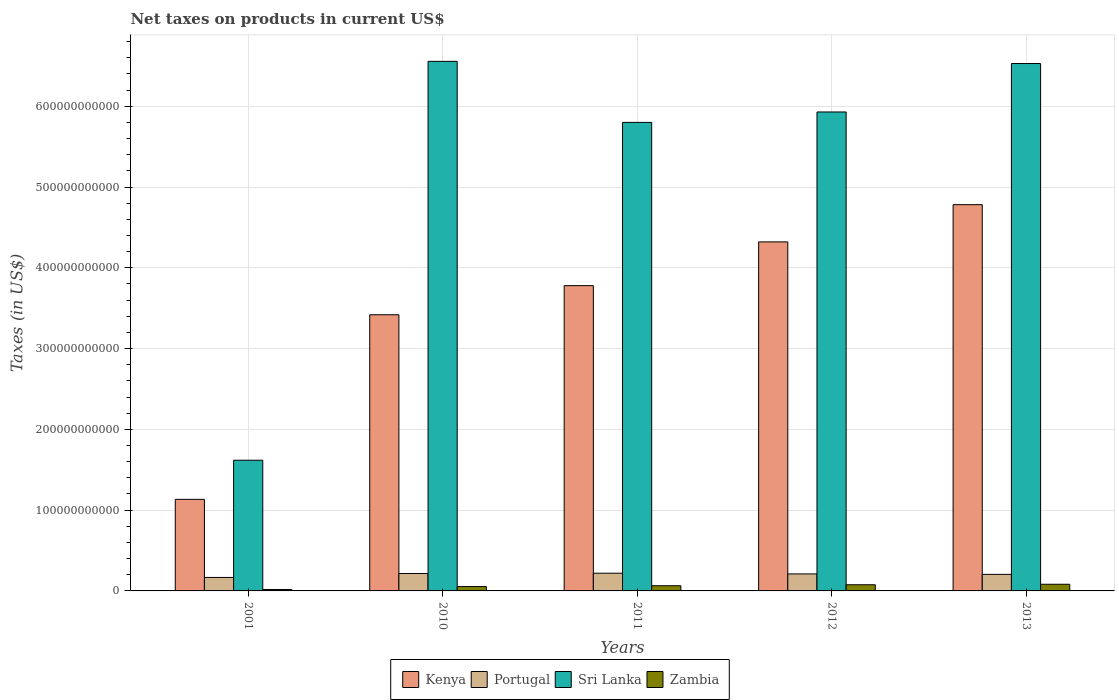How many different coloured bars are there?
Provide a short and direct response. 4. How many groups of bars are there?
Make the answer very short. 5. Are the number of bars per tick equal to the number of legend labels?
Keep it short and to the point. Yes. How many bars are there on the 5th tick from the left?
Your response must be concise. 4. In how many cases, is the number of bars for a given year not equal to the number of legend labels?
Give a very brief answer. 0. What is the net taxes on products in Sri Lanka in 2011?
Your answer should be very brief. 5.80e+11. Across all years, what is the maximum net taxes on products in Zambia?
Provide a short and direct response. 8.26e+09. Across all years, what is the minimum net taxes on products in Portugal?
Keep it short and to the point. 1.67e+1. In which year was the net taxes on products in Portugal maximum?
Provide a short and direct response. 2011. In which year was the net taxes on products in Portugal minimum?
Offer a very short reply. 2001. What is the total net taxes on products in Portugal in the graph?
Offer a very short reply. 1.02e+11. What is the difference between the net taxes on products in Sri Lanka in 2010 and that in 2011?
Offer a very short reply. 7.56e+1. What is the difference between the net taxes on products in Kenya in 2001 and the net taxes on products in Sri Lanka in 2012?
Provide a succinct answer. -4.80e+11. What is the average net taxes on products in Kenya per year?
Your response must be concise. 3.49e+11. In the year 2010, what is the difference between the net taxes on products in Kenya and net taxes on products in Portugal?
Ensure brevity in your answer.  3.20e+11. In how many years, is the net taxes on products in Kenya greater than 540000000000 US$?
Provide a short and direct response. 0. What is the ratio of the net taxes on products in Kenya in 2010 to that in 2012?
Offer a very short reply. 0.79. Is the difference between the net taxes on products in Kenya in 2010 and 2011 greater than the difference between the net taxes on products in Portugal in 2010 and 2011?
Offer a very short reply. No. What is the difference between the highest and the second highest net taxes on products in Portugal?
Give a very brief answer. 3.20e+08. What is the difference between the highest and the lowest net taxes on products in Zambia?
Offer a very short reply. 6.48e+09. Is the sum of the net taxes on products in Portugal in 2011 and 2012 greater than the maximum net taxes on products in Sri Lanka across all years?
Provide a short and direct response. No. Is it the case that in every year, the sum of the net taxes on products in Kenya and net taxes on products in Portugal is greater than the sum of net taxes on products in Zambia and net taxes on products in Sri Lanka?
Make the answer very short. Yes. What does the 1st bar from the left in 2011 represents?
Offer a terse response. Kenya. What does the 4th bar from the right in 2011 represents?
Ensure brevity in your answer.  Kenya. Is it the case that in every year, the sum of the net taxes on products in Sri Lanka and net taxes on products in Portugal is greater than the net taxes on products in Kenya?
Ensure brevity in your answer.  Yes. How many bars are there?
Ensure brevity in your answer.  20. How many years are there in the graph?
Your answer should be compact. 5. What is the difference between two consecutive major ticks on the Y-axis?
Your answer should be compact. 1.00e+11. Are the values on the major ticks of Y-axis written in scientific E-notation?
Ensure brevity in your answer.  No. Does the graph contain any zero values?
Keep it short and to the point. No. Does the graph contain grids?
Give a very brief answer. Yes. How many legend labels are there?
Provide a short and direct response. 4. How are the legend labels stacked?
Your answer should be compact. Horizontal. What is the title of the graph?
Keep it short and to the point. Net taxes on products in current US$. What is the label or title of the Y-axis?
Your answer should be very brief. Taxes (in US$). What is the Taxes (in US$) in Kenya in 2001?
Your response must be concise. 1.13e+11. What is the Taxes (in US$) in Portugal in 2001?
Keep it short and to the point. 1.67e+1. What is the Taxes (in US$) of Sri Lanka in 2001?
Provide a succinct answer. 1.62e+11. What is the Taxes (in US$) in Zambia in 2001?
Your answer should be very brief. 1.78e+09. What is the Taxes (in US$) in Kenya in 2010?
Provide a short and direct response. 3.42e+11. What is the Taxes (in US$) in Portugal in 2010?
Make the answer very short. 2.16e+1. What is the Taxes (in US$) in Sri Lanka in 2010?
Your answer should be compact. 6.56e+11. What is the Taxes (in US$) in Zambia in 2010?
Your response must be concise. 5.38e+09. What is the Taxes (in US$) in Kenya in 2011?
Your answer should be compact. 3.78e+11. What is the Taxes (in US$) in Portugal in 2011?
Your response must be concise. 2.19e+1. What is the Taxes (in US$) of Sri Lanka in 2011?
Your response must be concise. 5.80e+11. What is the Taxes (in US$) of Zambia in 2011?
Provide a succinct answer. 6.43e+09. What is the Taxes (in US$) of Kenya in 2012?
Make the answer very short. 4.32e+11. What is the Taxes (in US$) in Portugal in 2012?
Offer a very short reply. 2.10e+1. What is the Taxes (in US$) in Sri Lanka in 2012?
Your answer should be compact. 5.93e+11. What is the Taxes (in US$) in Zambia in 2012?
Your response must be concise. 7.63e+09. What is the Taxes (in US$) of Kenya in 2013?
Keep it short and to the point. 4.78e+11. What is the Taxes (in US$) in Portugal in 2013?
Provide a short and direct response. 2.05e+1. What is the Taxes (in US$) of Sri Lanka in 2013?
Your response must be concise. 6.53e+11. What is the Taxes (in US$) in Zambia in 2013?
Your answer should be very brief. 8.26e+09. Across all years, what is the maximum Taxes (in US$) in Kenya?
Give a very brief answer. 4.78e+11. Across all years, what is the maximum Taxes (in US$) in Portugal?
Provide a succinct answer. 2.19e+1. Across all years, what is the maximum Taxes (in US$) in Sri Lanka?
Keep it short and to the point. 6.56e+11. Across all years, what is the maximum Taxes (in US$) of Zambia?
Provide a succinct answer. 8.26e+09. Across all years, what is the minimum Taxes (in US$) of Kenya?
Your answer should be very brief. 1.13e+11. Across all years, what is the minimum Taxes (in US$) in Portugal?
Ensure brevity in your answer.  1.67e+1. Across all years, what is the minimum Taxes (in US$) in Sri Lanka?
Offer a terse response. 1.62e+11. Across all years, what is the minimum Taxes (in US$) in Zambia?
Make the answer very short. 1.78e+09. What is the total Taxes (in US$) in Kenya in the graph?
Ensure brevity in your answer.  1.74e+12. What is the total Taxes (in US$) of Portugal in the graph?
Ensure brevity in your answer.  1.02e+11. What is the total Taxes (in US$) in Sri Lanka in the graph?
Make the answer very short. 2.64e+12. What is the total Taxes (in US$) of Zambia in the graph?
Your response must be concise. 2.95e+1. What is the difference between the Taxes (in US$) of Kenya in 2001 and that in 2010?
Keep it short and to the point. -2.29e+11. What is the difference between the Taxes (in US$) of Portugal in 2001 and that in 2010?
Your response must be concise. -4.92e+09. What is the difference between the Taxes (in US$) of Sri Lanka in 2001 and that in 2010?
Offer a terse response. -4.94e+11. What is the difference between the Taxes (in US$) of Zambia in 2001 and that in 2010?
Provide a succinct answer. -3.60e+09. What is the difference between the Taxes (in US$) in Kenya in 2001 and that in 2011?
Ensure brevity in your answer.  -2.65e+11. What is the difference between the Taxes (in US$) in Portugal in 2001 and that in 2011?
Keep it short and to the point. -5.24e+09. What is the difference between the Taxes (in US$) in Sri Lanka in 2001 and that in 2011?
Provide a short and direct response. -4.18e+11. What is the difference between the Taxes (in US$) in Zambia in 2001 and that in 2011?
Ensure brevity in your answer.  -4.65e+09. What is the difference between the Taxes (in US$) in Kenya in 2001 and that in 2012?
Your answer should be compact. -3.19e+11. What is the difference between the Taxes (in US$) of Portugal in 2001 and that in 2012?
Provide a short and direct response. -4.35e+09. What is the difference between the Taxes (in US$) of Sri Lanka in 2001 and that in 2012?
Make the answer very short. -4.31e+11. What is the difference between the Taxes (in US$) of Zambia in 2001 and that in 2012?
Provide a short and direct response. -5.86e+09. What is the difference between the Taxes (in US$) in Kenya in 2001 and that in 2013?
Offer a terse response. -3.65e+11. What is the difference between the Taxes (in US$) in Portugal in 2001 and that in 2013?
Provide a short and direct response. -3.82e+09. What is the difference between the Taxes (in US$) of Sri Lanka in 2001 and that in 2013?
Ensure brevity in your answer.  -4.91e+11. What is the difference between the Taxes (in US$) in Zambia in 2001 and that in 2013?
Offer a terse response. -6.48e+09. What is the difference between the Taxes (in US$) of Kenya in 2010 and that in 2011?
Give a very brief answer. -3.61e+1. What is the difference between the Taxes (in US$) of Portugal in 2010 and that in 2011?
Make the answer very short. -3.20e+08. What is the difference between the Taxes (in US$) in Sri Lanka in 2010 and that in 2011?
Your answer should be compact. 7.56e+1. What is the difference between the Taxes (in US$) of Zambia in 2010 and that in 2011?
Provide a succinct answer. -1.05e+09. What is the difference between the Taxes (in US$) in Kenya in 2010 and that in 2012?
Make the answer very short. -9.02e+1. What is the difference between the Taxes (in US$) of Portugal in 2010 and that in 2012?
Provide a short and direct response. 5.68e+08. What is the difference between the Taxes (in US$) in Sri Lanka in 2010 and that in 2012?
Provide a short and direct response. 6.27e+1. What is the difference between the Taxes (in US$) of Zambia in 2010 and that in 2012?
Offer a terse response. -2.25e+09. What is the difference between the Taxes (in US$) of Kenya in 2010 and that in 2013?
Offer a very short reply. -1.36e+11. What is the difference between the Taxes (in US$) of Portugal in 2010 and that in 2013?
Your response must be concise. 1.10e+09. What is the difference between the Taxes (in US$) of Sri Lanka in 2010 and that in 2013?
Provide a short and direct response. 2.69e+09. What is the difference between the Taxes (in US$) of Zambia in 2010 and that in 2013?
Ensure brevity in your answer.  -2.88e+09. What is the difference between the Taxes (in US$) in Kenya in 2011 and that in 2012?
Your answer should be very brief. -5.41e+1. What is the difference between the Taxes (in US$) in Portugal in 2011 and that in 2012?
Your answer should be compact. 8.87e+08. What is the difference between the Taxes (in US$) of Sri Lanka in 2011 and that in 2012?
Make the answer very short. -1.29e+1. What is the difference between the Taxes (in US$) of Zambia in 2011 and that in 2012?
Provide a short and direct response. -1.21e+09. What is the difference between the Taxes (in US$) in Kenya in 2011 and that in 2013?
Keep it short and to the point. -1.00e+11. What is the difference between the Taxes (in US$) in Portugal in 2011 and that in 2013?
Make the answer very short. 1.42e+09. What is the difference between the Taxes (in US$) of Sri Lanka in 2011 and that in 2013?
Provide a short and direct response. -7.29e+1. What is the difference between the Taxes (in US$) of Zambia in 2011 and that in 2013?
Ensure brevity in your answer.  -1.83e+09. What is the difference between the Taxes (in US$) of Kenya in 2012 and that in 2013?
Ensure brevity in your answer.  -4.61e+1. What is the difference between the Taxes (in US$) in Portugal in 2012 and that in 2013?
Provide a succinct answer. 5.35e+08. What is the difference between the Taxes (in US$) in Sri Lanka in 2012 and that in 2013?
Offer a very short reply. -6.00e+1. What is the difference between the Taxes (in US$) in Zambia in 2012 and that in 2013?
Your response must be concise. -6.24e+08. What is the difference between the Taxes (in US$) of Kenya in 2001 and the Taxes (in US$) of Portugal in 2010?
Offer a terse response. 9.17e+1. What is the difference between the Taxes (in US$) of Kenya in 2001 and the Taxes (in US$) of Sri Lanka in 2010?
Give a very brief answer. -5.42e+11. What is the difference between the Taxes (in US$) in Kenya in 2001 and the Taxes (in US$) in Zambia in 2010?
Provide a succinct answer. 1.08e+11. What is the difference between the Taxes (in US$) of Portugal in 2001 and the Taxes (in US$) of Sri Lanka in 2010?
Give a very brief answer. -6.39e+11. What is the difference between the Taxes (in US$) in Portugal in 2001 and the Taxes (in US$) in Zambia in 2010?
Your answer should be compact. 1.13e+1. What is the difference between the Taxes (in US$) of Sri Lanka in 2001 and the Taxes (in US$) of Zambia in 2010?
Keep it short and to the point. 1.56e+11. What is the difference between the Taxes (in US$) in Kenya in 2001 and the Taxes (in US$) in Portugal in 2011?
Make the answer very short. 9.14e+1. What is the difference between the Taxes (in US$) in Kenya in 2001 and the Taxes (in US$) in Sri Lanka in 2011?
Your response must be concise. -4.67e+11. What is the difference between the Taxes (in US$) of Kenya in 2001 and the Taxes (in US$) of Zambia in 2011?
Keep it short and to the point. 1.07e+11. What is the difference between the Taxes (in US$) of Portugal in 2001 and the Taxes (in US$) of Sri Lanka in 2011?
Provide a short and direct response. -5.63e+11. What is the difference between the Taxes (in US$) in Portugal in 2001 and the Taxes (in US$) in Zambia in 2011?
Your answer should be compact. 1.03e+1. What is the difference between the Taxes (in US$) of Sri Lanka in 2001 and the Taxes (in US$) of Zambia in 2011?
Your answer should be very brief. 1.55e+11. What is the difference between the Taxes (in US$) in Kenya in 2001 and the Taxes (in US$) in Portugal in 2012?
Your answer should be very brief. 9.23e+1. What is the difference between the Taxes (in US$) of Kenya in 2001 and the Taxes (in US$) of Sri Lanka in 2012?
Keep it short and to the point. -4.80e+11. What is the difference between the Taxes (in US$) of Kenya in 2001 and the Taxes (in US$) of Zambia in 2012?
Provide a succinct answer. 1.06e+11. What is the difference between the Taxes (in US$) of Portugal in 2001 and the Taxes (in US$) of Sri Lanka in 2012?
Offer a terse response. -5.76e+11. What is the difference between the Taxes (in US$) of Portugal in 2001 and the Taxes (in US$) of Zambia in 2012?
Your answer should be very brief. 9.05e+09. What is the difference between the Taxes (in US$) in Sri Lanka in 2001 and the Taxes (in US$) in Zambia in 2012?
Offer a very short reply. 1.54e+11. What is the difference between the Taxes (in US$) in Kenya in 2001 and the Taxes (in US$) in Portugal in 2013?
Make the answer very short. 9.28e+1. What is the difference between the Taxes (in US$) in Kenya in 2001 and the Taxes (in US$) in Sri Lanka in 2013?
Your response must be concise. -5.40e+11. What is the difference between the Taxes (in US$) in Kenya in 2001 and the Taxes (in US$) in Zambia in 2013?
Your answer should be very brief. 1.05e+11. What is the difference between the Taxes (in US$) of Portugal in 2001 and the Taxes (in US$) of Sri Lanka in 2013?
Make the answer very short. -6.36e+11. What is the difference between the Taxes (in US$) of Portugal in 2001 and the Taxes (in US$) of Zambia in 2013?
Your answer should be very brief. 8.43e+09. What is the difference between the Taxes (in US$) of Sri Lanka in 2001 and the Taxes (in US$) of Zambia in 2013?
Your answer should be very brief. 1.54e+11. What is the difference between the Taxes (in US$) of Kenya in 2010 and the Taxes (in US$) of Portugal in 2011?
Your answer should be very brief. 3.20e+11. What is the difference between the Taxes (in US$) of Kenya in 2010 and the Taxes (in US$) of Sri Lanka in 2011?
Give a very brief answer. -2.38e+11. What is the difference between the Taxes (in US$) of Kenya in 2010 and the Taxes (in US$) of Zambia in 2011?
Offer a very short reply. 3.35e+11. What is the difference between the Taxes (in US$) in Portugal in 2010 and the Taxes (in US$) in Sri Lanka in 2011?
Ensure brevity in your answer.  -5.58e+11. What is the difference between the Taxes (in US$) in Portugal in 2010 and the Taxes (in US$) in Zambia in 2011?
Your answer should be compact. 1.52e+1. What is the difference between the Taxes (in US$) of Sri Lanka in 2010 and the Taxes (in US$) of Zambia in 2011?
Make the answer very short. 6.49e+11. What is the difference between the Taxes (in US$) in Kenya in 2010 and the Taxes (in US$) in Portugal in 2012?
Provide a short and direct response. 3.21e+11. What is the difference between the Taxes (in US$) of Kenya in 2010 and the Taxes (in US$) of Sri Lanka in 2012?
Provide a short and direct response. -2.51e+11. What is the difference between the Taxes (in US$) of Kenya in 2010 and the Taxes (in US$) of Zambia in 2012?
Offer a very short reply. 3.34e+11. What is the difference between the Taxes (in US$) in Portugal in 2010 and the Taxes (in US$) in Sri Lanka in 2012?
Your answer should be compact. -5.71e+11. What is the difference between the Taxes (in US$) of Portugal in 2010 and the Taxes (in US$) of Zambia in 2012?
Your response must be concise. 1.40e+1. What is the difference between the Taxes (in US$) in Sri Lanka in 2010 and the Taxes (in US$) in Zambia in 2012?
Provide a succinct answer. 6.48e+11. What is the difference between the Taxes (in US$) in Kenya in 2010 and the Taxes (in US$) in Portugal in 2013?
Make the answer very short. 3.21e+11. What is the difference between the Taxes (in US$) in Kenya in 2010 and the Taxes (in US$) in Sri Lanka in 2013?
Make the answer very short. -3.11e+11. What is the difference between the Taxes (in US$) of Kenya in 2010 and the Taxes (in US$) of Zambia in 2013?
Give a very brief answer. 3.34e+11. What is the difference between the Taxes (in US$) of Portugal in 2010 and the Taxes (in US$) of Sri Lanka in 2013?
Provide a short and direct response. -6.31e+11. What is the difference between the Taxes (in US$) of Portugal in 2010 and the Taxes (in US$) of Zambia in 2013?
Your answer should be very brief. 1.33e+1. What is the difference between the Taxes (in US$) of Sri Lanka in 2010 and the Taxes (in US$) of Zambia in 2013?
Give a very brief answer. 6.47e+11. What is the difference between the Taxes (in US$) of Kenya in 2011 and the Taxes (in US$) of Portugal in 2012?
Provide a short and direct response. 3.57e+11. What is the difference between the Taxes (in US$) of Kenya in 2011 and the Taxes (in US$) of Sri Lanka in 2012?
Provide a succinct answer. -2.15e+11. What is the difference between the Taxes (in US$) of Kenya in 2011 and the Taxes (in US$) of Zambia in 2012?
Keep it short and to the point. 3.70e+11. What is the difference between the Taxes (in US$) in Portugal in 2011 and the Taxes (in US$) in Sri Lanka in 2012?
Your response must be concise. -5.71e+11. What is the difference between the Taxes (in US$) of Portugal in 2011 and the Taxes (in US$) of Zambia in 2012?
Your answer should be compact. 1.43e+1. What is the difference between the Taxes (in US$) of Sri Lanka in 2011 and the Taxes (in US$) of Zambia in 2012?
Make the answer very short. 5.72e+11. What is the difference between the Taxes (in US$) of Kenya in 2011 and the Taxes (in US$) of Portugal in 2013?
Your response must be concise. 3.57e+11. What is the difference between the Taxes (in US$) of Kenya in 2011 and the Taxes (in US$) of Sri Lanka in 2013?
Provide a succinct answer. -2.75e+11. What is the difference between the Taxes (in US$) of Kenya in 2011 and the Taxes (in US$) of Zambia in 2013?
Your answer should be compact. 3.70e+11. What is the difference between the Taxes (in US$) of Portugal in 2011 and the Taxes (in US$) of Sri Lanka in 2013?
Give a very brief answer. -6.31e+11. What is the difference between the Taxes (in US$) of Portugal in 2011 and the Taxes (in US$) of Zambia in 2013?
Keep it short and to the point. 1.37e+1. What is the difference between the Taxes (in US$) in Sri Lanka in 2011 and the Taxes (in US$) in Zambia in 2013?
Keep it short and to the point. 5.72e+11. What is the difference between the Taxes (in US$) in Kenya in 2012 and the Taxes (in US$) in Portugal in 2013?
Keep it short and to the point. 4.12e+11. What is the difference between the Taxes (in US$) in Kenya in 2012 and the Taxes (in US$) in Sri Lanka in 2013?
Give a very brief answer. -2.21e+11. What is the difference between the Taxes (in US$) of Kenya in 2012 and the Taxes (in US$) of Zambia in 2013?
Your answer should be compact. 4.24e+11. What is the difference between the Taxes (in US$) of Portugal in 2012 and the Taxes (in US$) of Sri Lanka in 2013?
Your answer should be very brief. -6.32e+11. What is the difference between the Taxes (in US$) of Portugal in 2012 and the Taxes (in US$) of Zambia in 2013?
Give a very brief answer. 1.28e+1. What is the difference between the Taxes (in US$) of Sri Lanka in 2012 and the Taxes (in US$) of Zambia in 2013?
Your response must be concise. 5.85e+11. What is the average Taxes (in US$) in Kenya per year?
Provide a succinct answer. 3.49e+11. What is the average Taxes (in US$) in Portugal per year?
Make the answer very short. 2.03e+1. What is the average Taxes (in US$) of Sri Lanka per year?
Provide a short and direct response. 5.29e+11. What is the average Taxes (in US$) of Zambia per year?
Provide a succinct answer. 5.89e+09. In the year 2001, what is the difference between the Taxes (in US$) of Kenya and Taxes (in US$) of Portugal?
Offer a very short reply. 9.67e+1. In the year 2001, what is the difference between the Taxes (in US$) in Kenya and Taxes (in US$) in Sri Lanka?
Provide a succinct answer. -4.85e+1. In the year 2001, what is the difference between the Taxes (in US$) of Kenya and Taxes (in US$) of Zambia?
Your response must be concise. 1.12e+11. In the year 2001, what is the difference between the Taxes (in US$) of Portugal and Taxes (in US$) of Sri Lanka?
Ensure brevity in your answer.  -1.45e+11. In the year 2001, what is the difference between the Taxes (in US$) in Portugal and Taxes (in US$) in Zambia?
Give a very brief answer. 1.49e+1. In the year 2001, what is the difference between the Taxes (in US$) in Sri Lanka and Taxes (in US$) in Zambia?
Your answer should be compact. 1.60e+11. In the year 2010, what is the difference between the Taxes (in US$) of Kenya and Taxes (in US$) of Portugal?
Offer a very short reply. 3.20e+11. In the year 2010, what is the difference between the Taxes (in US$) of Kenya and Taxes (in US$) of Sri Lanka?
Your response must be concise. -3.14e+11. In the year 2010, what is the difference between the Taxes (in US$) of Kenya and Taxes (in US$) of Zambia?
Make the answer very short. 3.36e+11. In the year 2010, what is the difference between the Taxes (in US$) in Portugal and Taxes (in US$) in Sri Lanka?
Offer a terse response. -6.34e+11. In the year 2010, what is the difference between the Taxes (in US$) of Portugal and Taxes (in US$) of Zambia?
Offer a terse response. 1.62e+1. In the year 2010, what is the difference between the Taxes (in US$) in Sri Lanka and Taxes (in US$) in Zambia?
Keep it short and to the point. 6.50e+11. In the year 2011, what is the difference between the Taxes (in US$) in Kenya and Taxes (in US$) in Portugal?
Make the answer very short. 3.56e+11. In the year 2011, what is the difference between the Taxes (in US$) of Kenya and Taxes (in US$) of Sri Lanka?
Make the answer very short. -2.02e+11. In the year 2011, what is the difference between the Taxes (in US$) of Kenya and Taxes (in US$) of Zambia?
Keep it short and to the point. 3.71e+11. In the year 2011, what is the difference between the Taxes (in US$) in Portugal and Taxes (in US$) in Sri Lanka?
Your answer should be compact. -5.58e+11. In the year 2011, what is the difference between the Taxes (in US$) of Portugal and Taxes (in US$) of Zambia?
Keep it short and to the point. 1.55e+1. In the year 2011, what is the difference between the Taxes (in US$) of Sri Lanka and Taxes (in US$) of Zambia?
Your response must be concise. 5.74e+11. In the year 2012, what is the difference between the Taxes (in US$) in Kenya and Taxes (in US$) in Portugal?
Offer a very short reply. 4.11e+11. In the year 2012, what is the difference between the Taxes (in US$) in Kenya and Taxes (in US$) in Sri Lanka?
Your response must be concise. -1.61e+11. In the year 2012, what is the difference between the Taxes (in US$) of Kenya and Taxes (in US$) of Zambia?
Keep it short and to the point. 4.24e+11. In the year 2012, what is the difference between the Taxes (in US$) in Portugal and Taxes (in US$) in Sri Lanka?
Offer a very short reply. -5.72e+11. In the year 2012, what is the difference between the Taxes (in US$) in Portugal and Taxes (in US$) in Zambia?
Provide a succinct answer. 1.34e+1. In the year 2012, what is the difference between the Taxes (in US$) in Sri Lanka and Taxes (in US$) in Zambia?
Provide a succinct answer. 5.85e+11. In the year 2013, what is the difference between the Taxes (in US$) in Kenya and Taxes (in US$) in Portugal?
Provide a short and direct response. 4.58e+11. In the year 2013, what is the difference between the Taxes (in US$) in Kenya and Taxes (in US$) in Sri Lanka?
Ensure brevity in your answer.  -1.75e+11. In the year 2013, what is the difference between the Taxes (in US$) in Kenya and Taxes (in US$) in Zambia?
Your answer should be compact. 4.70e+11. In the year 2013, what is the difference between the Taxes (in US$) of Portugal and Taxes (in US$) of Sri Lanka?
Keep it short and to the point. -6.32e+11. In the year 2013, what is the difference between the Taxes (in US$) in Portugal and Taxes (in US$) in Zambia?
Make the answer very short. 1.22e+1. In the year 2013, what is the difference between the Taxes (in US$) in Sri Lanka and Taxes (in US$) in Zambia?
Provide a short and direct response. 6.45e+11. What is the ratio of the Taxes (in US$) of Kenya in 2001 to that in 2010?
Provide a short and direct response. 0.33. What is the ratio of the Taxes (in US$) of Portugal in 2001 to that in 2010?
Your answer should be compact. 0.77. What is the ratio of the Taxes (in US$) in Sri Lanka in 2001 to that in 2010?
Your answer should be compact. 0.25. What is the ratio of the Taxes (in US$) of Zambia in 2001 to that in 2010?
Your answer should be compact. 0.33. What is the ratio of the Taxes (in US$) of Kenya in 2001 to that in 2011?
Your answer should be very brief. 0.3. What is the ratio of the Taxes (in US$) in Portugal in 2001 to that in 2011?
Provide a succinct answer. 0.76. What is the ratio of the Taxes (in US$) of Sri Lanka in 2001 to that in 2011?
Make the answer very short. 0.28. What is the ratio of the Taxes (in US$) of Zambia in 2001 to that in 2011?
Provide a short and direct response. 0.28. What is the ratio of the Taxes (in US$) of Kenya in 2001 to that in 2012?
Ensure brevity in your answer.  0.26. What is the ratio of the Taxes (in US$) in Portugal in 2001 to that in 2012?
Your response must be concise. 0.79. What is the ratio of the Taxes (in US$) of Sri Lanka in 2001 to that in 2012?
Make the answer very short. 0.27. What is the ratio of the Taxes (in US$) of Zambia in 2001 to that in 2012?
Provide a short and direct response. 0.23. What is the ratio of the Taxes (in US$) in Kenya in 2001 to that in 2013?
Give a very brief answer. 0.24. What is the ratio of the Taxes (in US$) of Portugal in 2001 to that in 2013?
Ensure brevity in your answer.  0.81. What is the ratio of the Taxes (in US$) in Sri Lanka in 2001 to that in 2013?
Your response must be concise. 0.25. What is the ratio of the Taxes (in US$) in Zambia in 2001 to that in 2013?
Make the answer very short. 0.22. What is the ratio of the Taxes (in US$) in Kenya in 2010 to that in 2011?
Give a very brief answer. 0.9. What is the ratio of the Taxes (in US$) of Portugal in 2010 to that in 2011?
Make the answer very short. 0.99. What is the ratio of the Taxes (in US$) of Sri Lanka in 2010 to that in 2011?
Give a very brief answer. 1.13. What is the ratio of the Taxes (in US$) in Zambia in 2010 to that in 2011?
Offer a terse response. 0.84. What is the ratio of the Taxes (in US$) of Kenya in 2010 to that in 2012?
Your answer should be very brief. 0.79. What is the ratio of the Taxes (in US$) in Sri Lanka in 2010 to that in 2012?
Provide a succinct answer. 1.11. What is the ratio of the Taxes (in US$) of Zambia in 2010 to that in 2012?
Give a very brief answer. 0.7. What is the ratio of the Taxes (in US$) of Kenya in 2010 to that in 2013?
Your answer should be very brief. 0.71. What is the ratio of the Taxes (in US$) in Portugal in 2010 to that in 2013?
Ensure brevity in your answer.  1.05. What is the ratio of the Taxes (in US$) in Sri Lanka in 2010 to that in 2013?
Provide a short and direct response. 1. What is the ratio of the Taxes (in US$) of Zambia in 2010 to that in 2013?
Make the answer very short. 0.65. What is the ratio of the Taxes (in US$) of Kenya in 2011 to that in 2012?
Offer a terse response. 0.87. What is the ratio of the Taxes (in US$) of Portugal in 2011 to that in 2012?
Make the answer very short. 1.04. What is the ratio of the Taxes (in US$) of Sri Lanka in 2011 to that in 2012?
Your answer should be compact. 0.98. What is the ratio of the Taxes (in US$) of Zambia in 2011 to that in 2012?
Provide a short and direct response. 0.84. What is the ratio of the Taxes (in US$) of Kenya in 2011 to that in 2013?
Give a very brief answer. 0.79. What is the ratio of the Taxes (in US$) of Portugal in 2011 to that in 2013?
Your response must be concise. 1.07. What is the ratio of the Taxes (in US$) in Sri Lanka in 2011 to that in 2013?
Provide a short and direct response. 0.89. What is the ratio of the Taxes (in US$) of Zambia in 2011 to that in 2013?
Your response must be concise. 0.78. What is the ratio of the Taxes (in US$) of Kenya in 2012 to that in 2013?
Keep it short and to the point. 0.9. What is the ratio of the Taxes (in US$) in Portugal in 2012 to that in 2013?
Make the answer very short. 1.03. What is the ratio of the Taxes (in US$) in Sri Lanka in 2012 to that in 2013?
Offer a terse response. 0.91. What is the ratio of the Taxes (in US$) of Zambia in 2012 to that in 2013?
Your answer should be very brief. 0.92. What is the difference between the highest and the second highest Taxes (in US$) of Kenya?
Your response must be concise. 4.61e+1. What is the difference between the highest and the second highest Taxes (in US$) in Portugal?
Your response must be concise. 3.20e+08. What is the difference between the highest and the second highest Taxes (in US$) in Sri Lanka?
Offer a terse response. 2.69e+09. What is the difference between the highest and the second highest Taxes (in US$) in Zambia?
Offer a very short reply. 6.24e+08. What is the difference between the highest and the lowest Taxes (in US$) of Kenya?
Your response must be concise. 3.65e+11. What is the difference between the highest and the lowest Taxes (in US$) of Portugal?
Keep it short and to the point. 5.24e+09. What is the difference between the highest and the lowest Taxes (in US$) in Sri Lanka?
Your answer should be compact. 4.94e+11. What is the difference between the highest and the lowest Taxes (in US$) in Zambia?
Your answer should be very brief. 6.48e+09. 